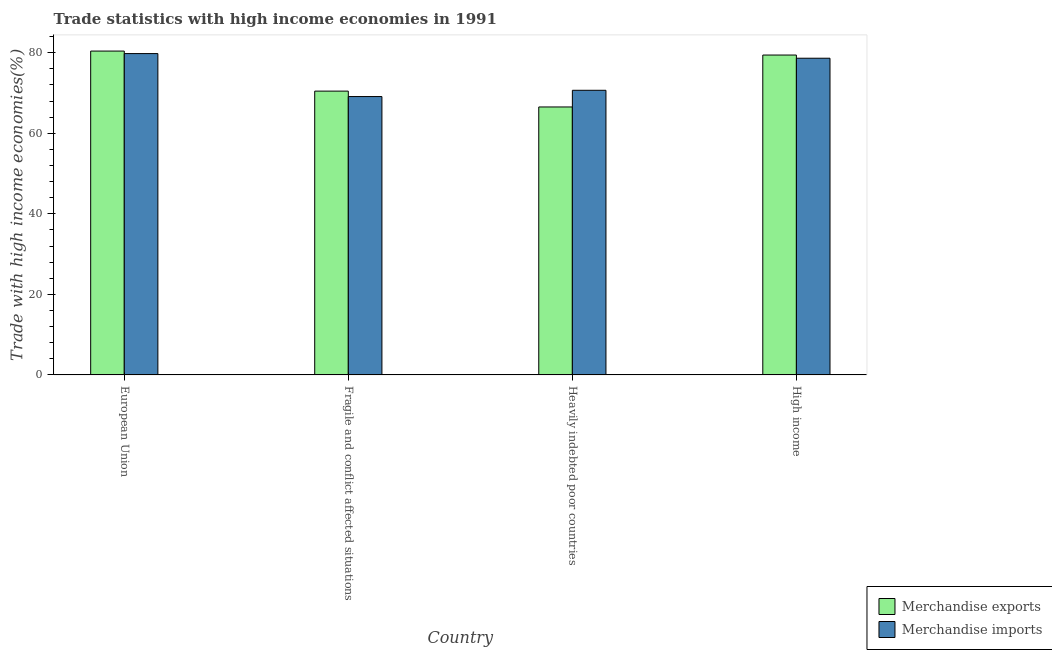How many groups of bars are there?
Your answer should be very brief. 4. How many bars are there on the 1st tick from the right?
Ensure brevity in your answer.  2. What is the label of the 1st group of bars from the left?
Your answer should be very brief. European Union. What is the merchandise exports in Heavily indebted poor countries?
Provide a short and direct response. 66.54. Across all countries, what is the maximum merchandise exports?
Keep it short and to the point. 80.43. Across all countries, what is the minimum merchandise exports?
Provide a succinct answer. 66.54. In which country was the merchandise imports minimum?
Give a very brief answer. Fragile and conflict affected situations. What is the total merchandise imports in the graph?
Give a very brief answer. 298.27. What is the difference between the merchandise exports in Heavily indebted poor countries and that in High income?
Provide a short and direct response. -12.9. What is the difference between the merchandise imports in European Union and the merchandise exports in High income?
Ensure brevity in your answer.  0.36. What is the average merchandise imports per country?
Offer a terse response. 74.57. What is the difference between the merchandise imports and merchandise exports in High income?
Your answer should be very brief. -0.79. In how many countries, is the merchandise imports greater than 32 %?
Your response must be concise. 4. What is the ratio of the merchandise imports in Fragile and conflict affected situations to that in Heavily indebted poor countries?
Your answer should be very brief. 0.98. Is the merchandise imports in Fragile and conflict affected situations less than that in Heavily indebted poor countries?
Your answer should be compact. Yes. Is the difference between the merchandise imports in Fragile and conflict affected situations and High income greater than the difference between the merchandise exports in Fragile and conflict affected situations and High income?
Give a very brief answer. No. What is the difference between the highest and the second highest merchandise imports?
Your answer should be very brief. 1.15. What is the difference between the highest and the lowest merchandise exports?
Offer a terse response. 13.88. Is the sum of the merchandise imports in European Union and Heavily indebted poor countries greater than the maximum merchandise exports across all countries?
Ensure brevity in your answer.  Yes. How many bars are there?
Your response must be concise. 8. Are all the bars in the graph horizontal?
Keep it short and to the point. No. How many countries are there in the graph?
Give a very brief answer. 4. Are the values on the major ticks of Y-axis written in scientific E-notation?
Ensure brevity in your answer.  No. Does the graph contain any zero values?
Offer a terse response. No. Does the graph contain grids?
Provide a short and direct response. No. How many legend labels are there?
Keep it short and to the point. 2. What is the title of the graph?
Keep it short and to the point. Trade statistics with high income economies in 1991. What is the label or title of the X-axis?
Your answer should be very brief. Country. What is the label or title of the Y-axis?
Provide a succinct answer. Trade with high income economies(%). What is the Trade with high income economies(%) of Merchandise exports in European Union?
Give a very brief answer. 80.43. What is the Trade with high income economies(%) in Merchandise imports in European Union?
Your answer should be very brief. 79.8. What is the Trade with high income economies(%) of Merchandise exports in Fragile and conflict affected situations?
Ensure brevity in your answer.  70.48. What is the Trade with high income economies(%) of Merchandise imports in Fragile and conflict affected situations?
Your answer should be compact. 69.13. What is the Trade with high income economies(%) of Merchandise exports in Heavily indebted poor countries?
Ensure brevity in your answer.  66.54. What is the Trade with high income economies(%) in Merchandise imports in Heavily indebted poor countries?
Offer a very short reply. 70.68. What is the Trade with high income economies(%) of Merchandise exports in High income?
Your answer should be very brief. 79.44. What is the Trade with high income economies(%) of Merchandise imports in High income?
Give a very brief answer. 78.65. Across all countries, what is the maximum Trade with high income economies(%) of Merchandise exports?
Provide a succinct answer. 80.43. Across all countries, what is the maximum Trade with high income economies(%) of Merchandise imports?
Offer a very short reply. 79.8. Across all countries, what is the minimum Trade with high income economies(%) of Merchandise exports?
Offer a very short reply. 66.54. Across all countries, what is the minimum Trade with high income economies(%) in Merchandise imports?
Keep it short and to the point. 69.13. What is the total Trade with high income economies(%) of Merchandise exports in the graph?
Make the answer very short. 296.89. What is the total Trade with high income economies(%) in Merchandise imports in the graph?
Provide a short and direct response. 298.27. What is the difference between the Trade with high income economies(%) of Merchandise exports in European Union and that in Fragile and conflict affected situations?
Offer a very short reply. 9.95. What is the difference between the Trade with high income economies(%) in Merchandise imports in European Union and that in Fragile and conflict affected situations?
Ensure brevity in your answer.  10.67. What is the difference between the Trade with high income economies(%) of Merchandise exports in European Union and that in Heavily indebted poor countries?
Your answer should be very brief. 13.88. What is the difference between the Trade with high income economies(%) in Merchandise imports in European Union and that in Heavily indebted poor countries?
Offer a very short reply. 9.12. What is the difference between the Trade with high income economies(%) in Merchandise exports in European Union and that in High income?
Give a very brief answer. 0.99. What is the difference between the Trade with high income economies(%) in Merchandise imports in European Union and that in High income?
Ensure brevity in your answer.  1.15. What is the difference between the Trade with high income economies(%) of Merchandise exports in Fragile and conflict affected situations and that in Heavily indebted poor countries?
Your response must be concise. 3.94. What is the difference between the Trade with high income economies(%) in Merchandise imports in Fragile and conflict affected situations and that in Heavily indebted poor countries?
Ensure brevity in your answer.  -1.55. What is the difference between the Trade with high income economies(%) of Merchandise exports in Fragile and conflict affected situations and that in High income?
Provide a succinct answer. -8.96. What is the difference between the Trade with high income economies(%) of Merchandise imports in Fragile and conflict affected situations and that in High income?
Your answer should be very brief. -9.52. What is the difference between the Trade with high income economies(%) of Merchandise exports in Heavily indebted poor countries and that in High income?
Make the answer very short. -12.9. What is the difference between the Trade with high income economies(%) in Merchandise imports in Heavily indebted poor countries and that in High income?
Offer a terse response. -7.97. What is the difference between the Trade with high income economies(%) of Merchandise exports in European Union and the Trade with high income economies(%) of Merchandise imports in Fragile and conflict affected situations?
Offer a very short reply. 11.29. What is the difference between the Trade with high income economies(%) in Merchandise exports in European Union and the Trade with high income economies(%) in Merchandise imports in Heavily indebted poor countries?
Ensure brevity in your answer.  9.74. What is the difference between the Trade with high income economies(%) of Merchandise exports in European Union and the Trade with high income economies(%) of Merchandise imports in High income?
Ensure brevity in your answer.  1.78. What is the difference between the Trade with high income economies(%) in Merchandise exports in Fragile and conflict affected situations and the Trade with high income economies(%) in Merchandise imports in Heavily indebted poor countries?
Provide a short and direct response. -0.2. What is the difference between the Trade with high income economies(%) in Merchandise exports in Fragile and conflict affected situations and the Trade with high income economies(%) in Merchandise imports in High income?
Offer a terse response. -8.17. What is the difference between the Trade with high income economies(%) of Merchandise exports in Heavily indebted poor countries and the Trade with high income economies(%) of Merchandise imports in High income?
Provide a short and direct response. -12.11. What is the average Trade with high income economies(%) of Merchandise exports per country?
Your answer should be very brief. 74.22. What is the average Trade with high income economies(%) in Merchandise imports per country?
Provide a succinct answer. 74.57. What is the difference between the Trade with high income economies(%) of Merchandise exports and Trade with high income economies(%) of Merchandise imports in European Union?
Offer a terse response. 0.62. What is the difference between the Trade with high income economies(%) of Merchandise exports and Trade with high income economies(%) of Merchandise imports in Fragile and conflict affected situations?
Make the answer very short. 1.35. What is the difference between the Trade with high income economies(%) of Merchandise exports and Trade with high income economies(%) of Merchandise imports in Heavily indebted poor countries?
Your answer should be very brief. -4.14. What is the difference between the Trade with high income economies(%) in Merchandise exports and Trade with high income economies(%) in Merchandise imports in High income?
Make the answer very short. 0.79. What is the ratio of the Trade with high income economies(%) of Merchandise exports in European Union to that in Fragile and conflict affected situations?
Give a very brief answer. 1.14. What is the ratio of the Trade with high income economies(%) of Merchandise imports in European Union to that in Fragile and conflict affected situations?
Give a very brief answer. 1.15. What is the ratio of the Trade with high income economies(%) in Merchandise exports in European Union to that in Heavily indebted poor countries?
Offer a terse response. 1.21. What is the ratio of the Trade with high income economies(%) in Merchandise imports in European Union to that in Heavily indebted poor countries?
Provide a short and direct response. 1.13. What is the ratio of the Trade with high income economies(%) of Merchandise exports in European Union to that in High income?
Offer a very short reply. 1.01. What is the ratio of the Trade with high income economies(%) in Merchandise imports in European Union to that in High income?
Keep it short and to the point. 1.01. What is the ratio of the Trade with high income economies(%) in Merchandise exports in Fragile and conflict affected situations to that in Heavily indebted poor countries?
Ensure brevity in your answer.  1.06. What is the ratio of the Trade with high income economies(%) of Merchandise imports in Fragile and conflict affected situations to that in Heavily indebted poor countries?
Ensure brevity in your answer.  0.98. What is the ratio of the Trade with high income economies(%) in Merchandise exports in Fragile and conflict affected situations to that in High income?
Offer a terse response. 0.89. What is the ratio of the Trade with high income economies(%) of Merchandise imports in Fragile and conflict affected situations to that in High income?
Your answer should be very brief. 0.88. What is the ratio of the Trade with high income economies(%) of Merchandise exports in Heavily indebted poor countries to that in High income?
Keep it short and to the point. 0.84. What is the ratio of the Trade with high income economies(%) of Merchandise imports in Heavily indebted poor countries to that in High income?
Give a very brief answer. 0.9. What is the difference between the highest and the second highest Trade with high income economies(%) in Merchandise exports?
Provide a short and direct response. 0.99. What is the difference between the highest and the second highest Trade with high income economies(%) in Merchandise imports?
Make the answer very short. 1.15. What is the difference between the highest and the lowest Trade with high income economies(%) of Merchandise exports?
Your answer should be compact. 13.88. What is the difference between the highest and the lowest Trade with high income economies(%) in Merchandise imports?
Provide a short and direct response. 10.67. 